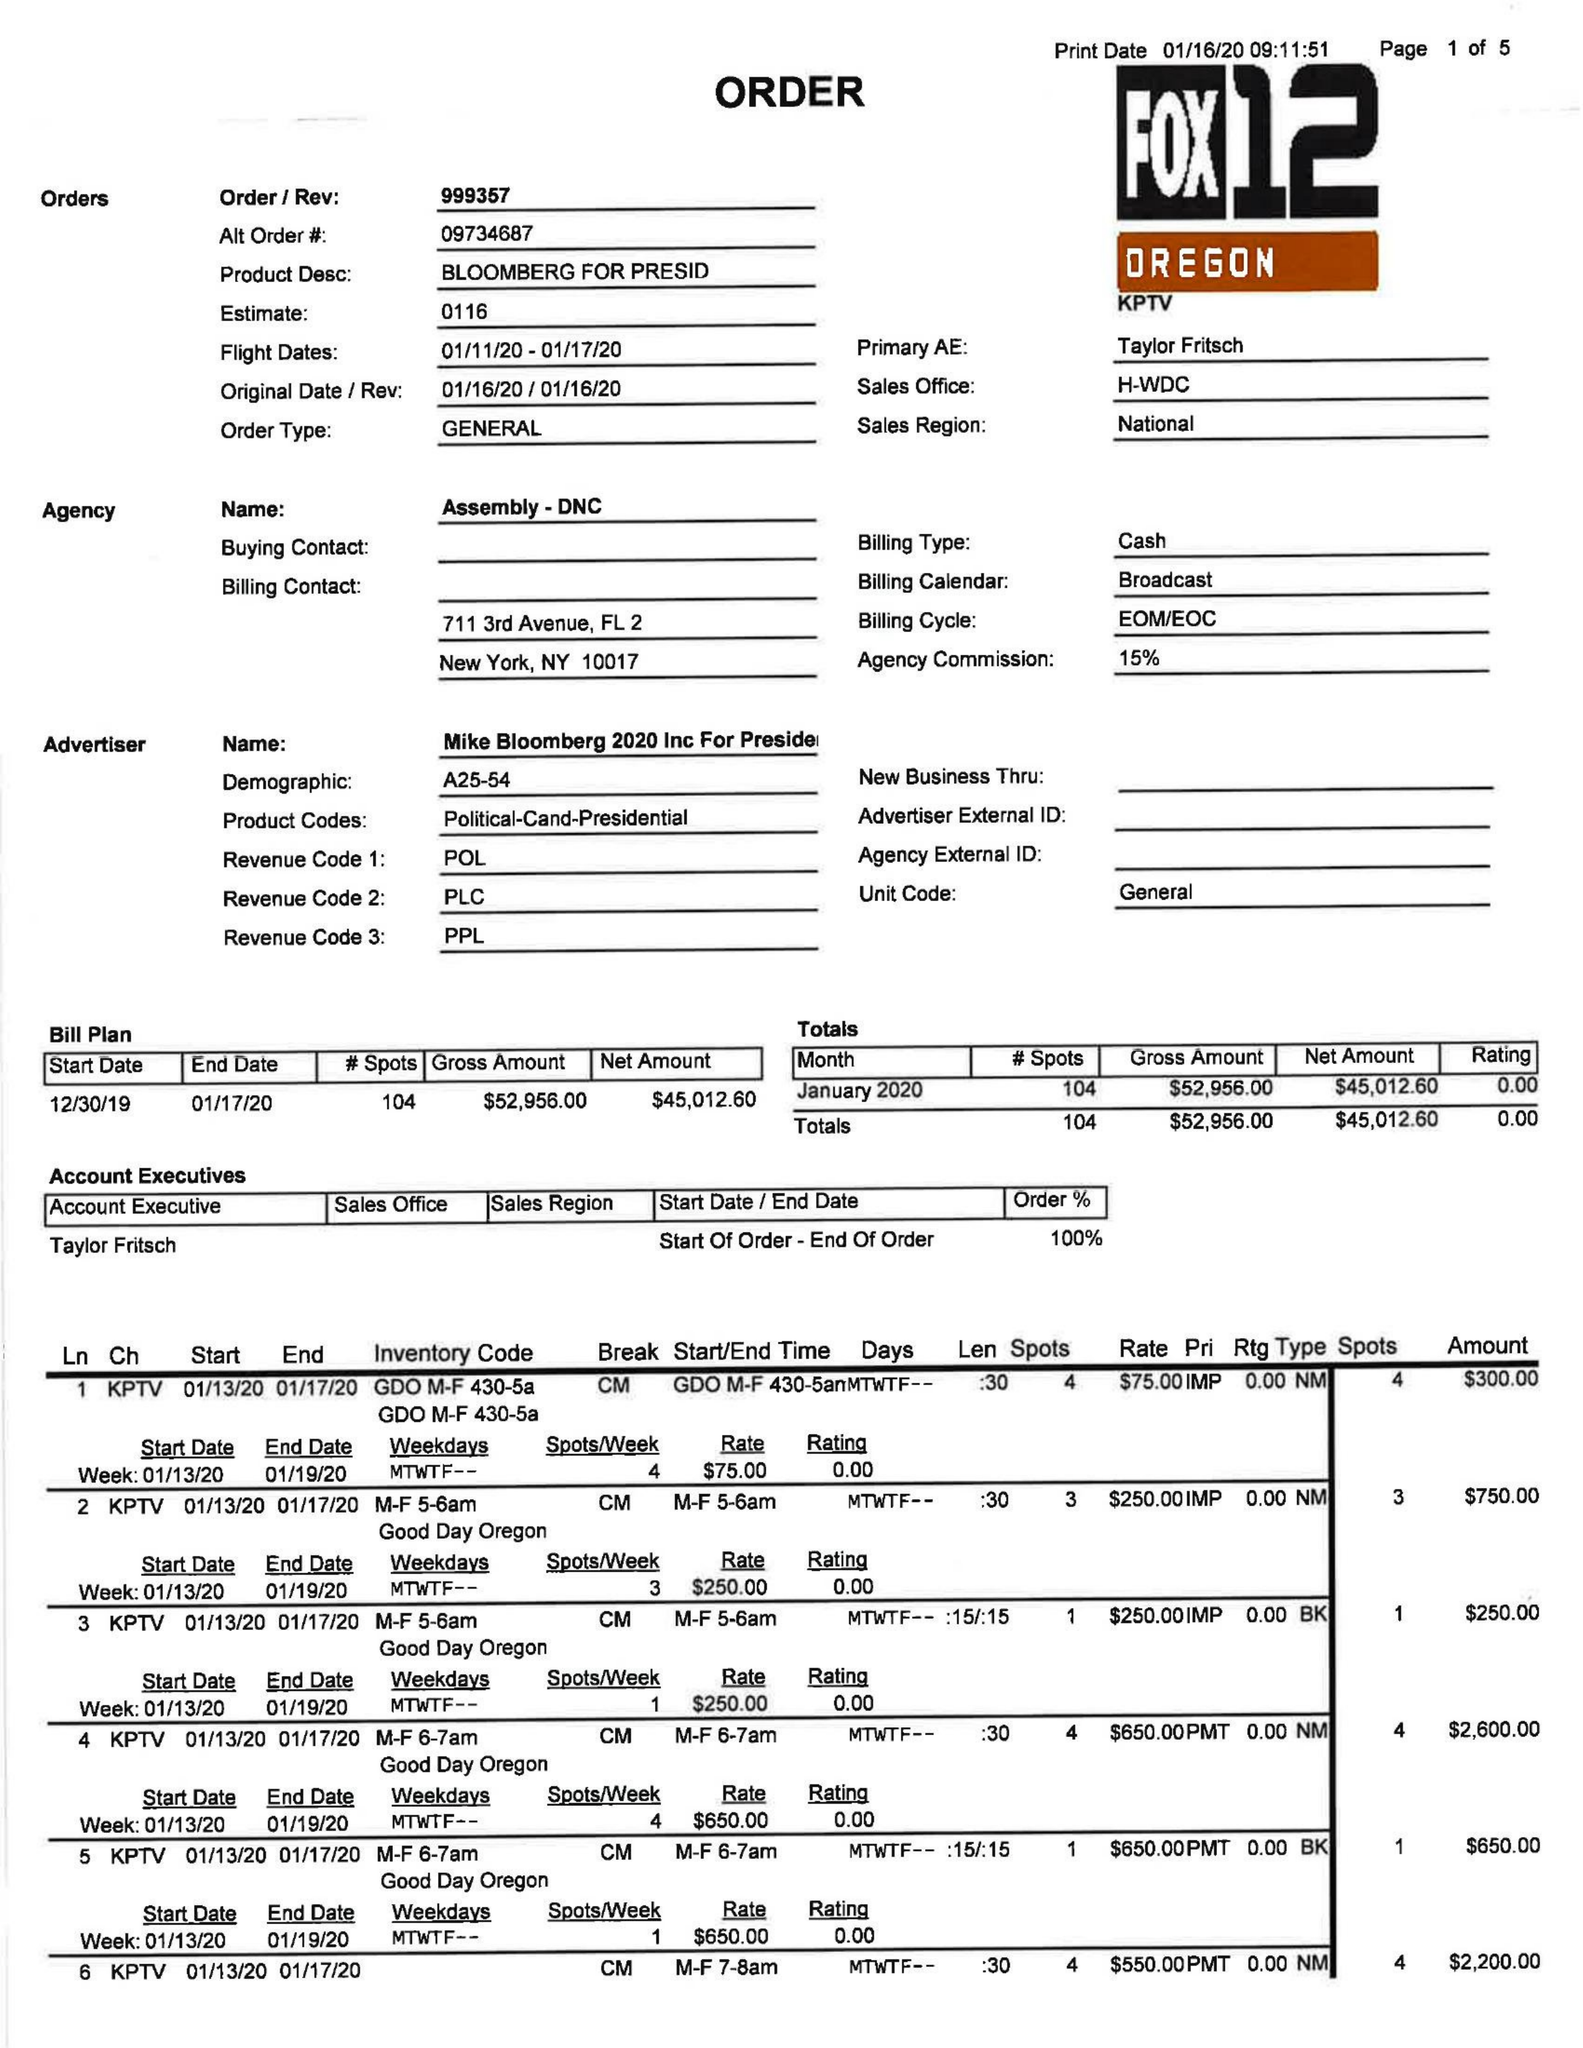What is the value for the flight_from?
Answer the question using a single word or phrase. 01/11/20 